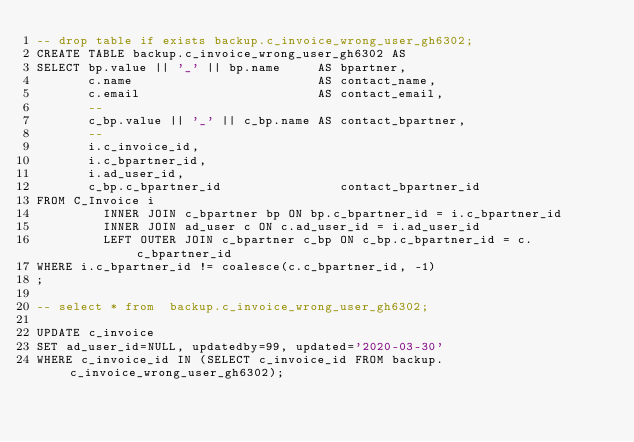<code> <loc_0><loc_0><loc_500><loc_500><_SQL_>-- drop table if exists backup.c_invoice_wrong_user_gh6302;
CREATE TABLE backup.c_invoice_wrong_user_gh6302 AS
SELECT bp.value || '_' || bp.name     AS bpartner,
       c.name                         AS contact_name,
       c.email                        AS contact_email,
       --
       c_bp.value || '_' || c_bp.name AS contact_bpartner,
       --
       i.c_invoice_id,
       i.c_bpartner_id,
       i.ad_user_id,
       c_bp.c_bpartner_id                contact_bpartner_id
FROM C_Invoice i
         INNER JOIN c_bpartner bp ON bp.c_bpartner_id = i.c_bpartner_id
         INNER JOIN ad_user c ON c.ad_user_id = i.ad_user_id
         LEFT OUTER JOIN c_bpartner c_bp ON c_bp.c_bpartner_id = c.c_bpartner_id
WHERE i.c_bpartner_id != coalesce(c.c_bpartner_id, -1)
;

-- select * from  backup.c_invoice_wrong_user_gh6302;

UPDATE c_invoice
SET ad_user_id=NULL, updatedby=99, updated='2020-03-30'
WHERE c_invoice_id IN (SELECT c_invoice_id FROM backup.c_invoice_wrong_user_gh6302);

</code> 